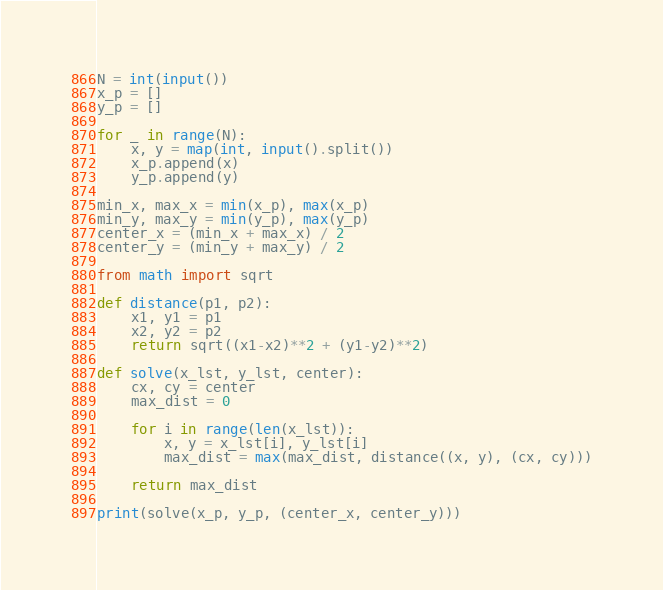Convert code to text. <code><loc_0><loc_0><loc_500><loc_500><_Python_>N = int(input())
x_p = []
y_p = []

for _ in range(N):
    x, y = map(int, input().split())
    x_p.append(x)
    y_p.append(y)

min_x, max_x = min(x_p), max(x_p)
min_y, max_y = min(y_p), max(y_p)
center_x = (min_x + max_x) / 2
center_y = (min_y + max_y) / 2

from math import sqrt

def distance(p1, p2):
    x1, y1 = p1
    x2, y2 = p2
    return sqrt((x1-x2)**2 + (y1-y2)**2)

def solve(x_lst, y_lst, center):
    cx, cy = center
    max_dist = 0

    for i in range(len(x_lst)):
        x, y = x_lst[i], y_lst[i]
        max_dist = max(max_dist, distance((x, y), (cx, cy)))
    
    return max_dist

print(solve(x_p, y_p, (center_x, center_y)))</code> 